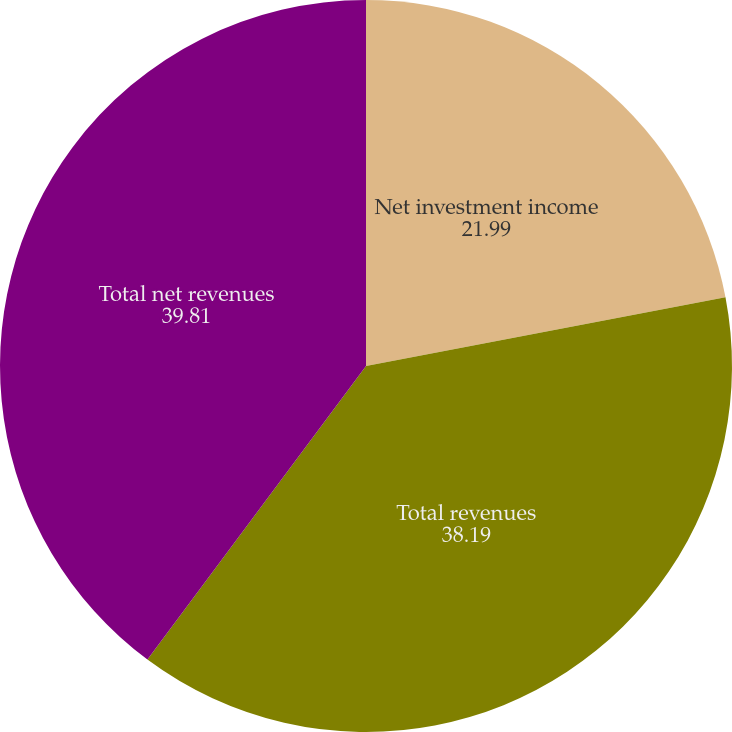Convert chart to OTSL. <chart><loc_0><loc_0><loc_500><loc_500><pie_chart><fcel>Net investment income<fcel>Total revenues<fcel>Total net revenues<nl><fcel>21.99%<fcel>38.19%<fcel>39.81%<nl></chart> 